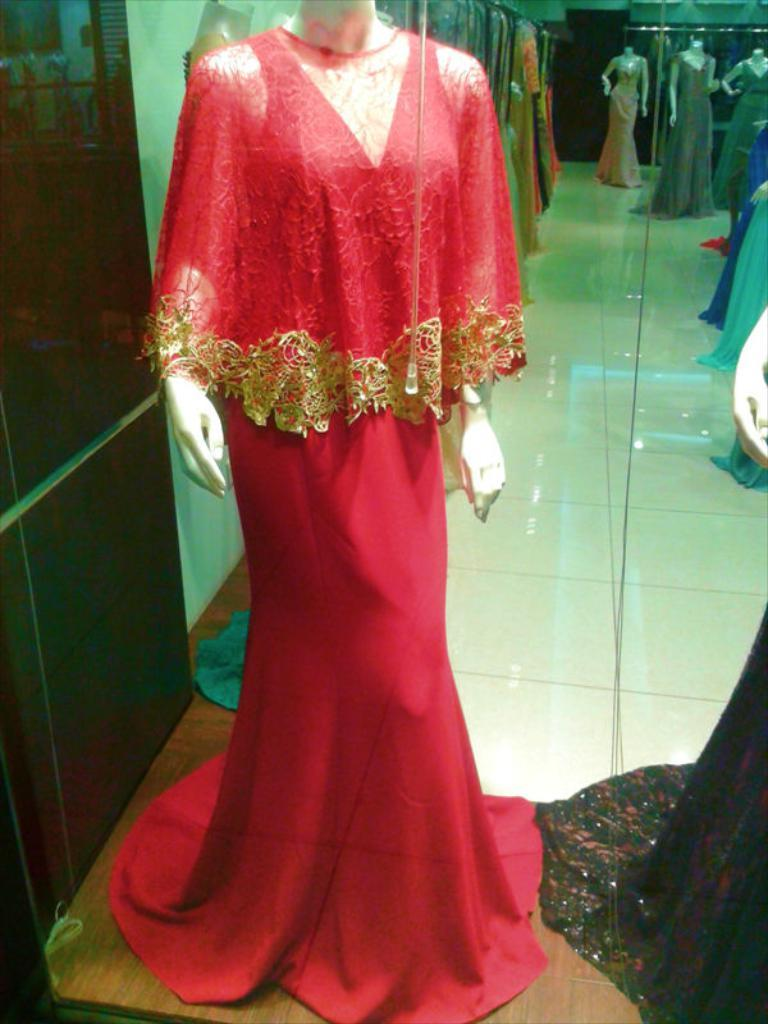What type of objects can be seen in the image? There are mannequins in the image. What surface can be seen beneath the mannequins? There is a floor visible in the image. Is there a yard visible in the image? There is no yard present in the image; it only shows mannequins and a floor. Is it raining in the image? There is no indication of rain in the image, as it only shows mannequins and a floor. 